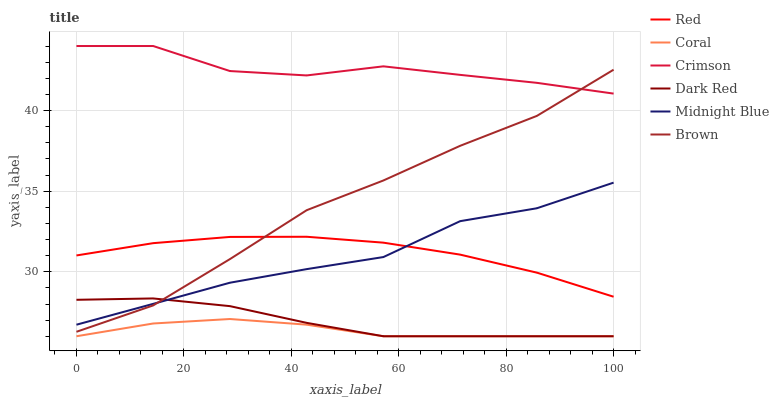Does Coral have the minimum area under the curve?
Answer yes or no. Yes. Does Crimson have the maximum area under the curve?
Answer yes or no. Yes. Does Midnight Blue have the minimum area under the curve?
Answer yes or no. No. Does Midnight Blue have the maximum area under the curve?
Answer yes or no. No. Is Dark Red the smoothest?
Answer yes or no. Yes. Is Crimson the roughest?
Answer yes or no. Yes. Is Midnight Blue the smoothest?
Answer yes or no. No. Is Midnight Blue the roughest?
Answer yes or no. No. Does Midnight Blue have the lowest value?
Answer yes or no. No. Does Crimson have the highest value?
Answer yes or no. Yes. Does Midnight Blue have the highest value?
Answer yes or no. No. Is Coral less than Red?
Answer yes or no. Yes. Is Red greater than Coral?
Answer yes or no. Yes. Does Brown intersect Midnight Blue?
Answer yes or no. Yes. Is Brown less than Midnight Blue?
Answer yes or no. No. Is Brown greater than Midnight Blue?
Answer yes or no. No. Does Coral intersect Red?
Answer yes or no. No. 